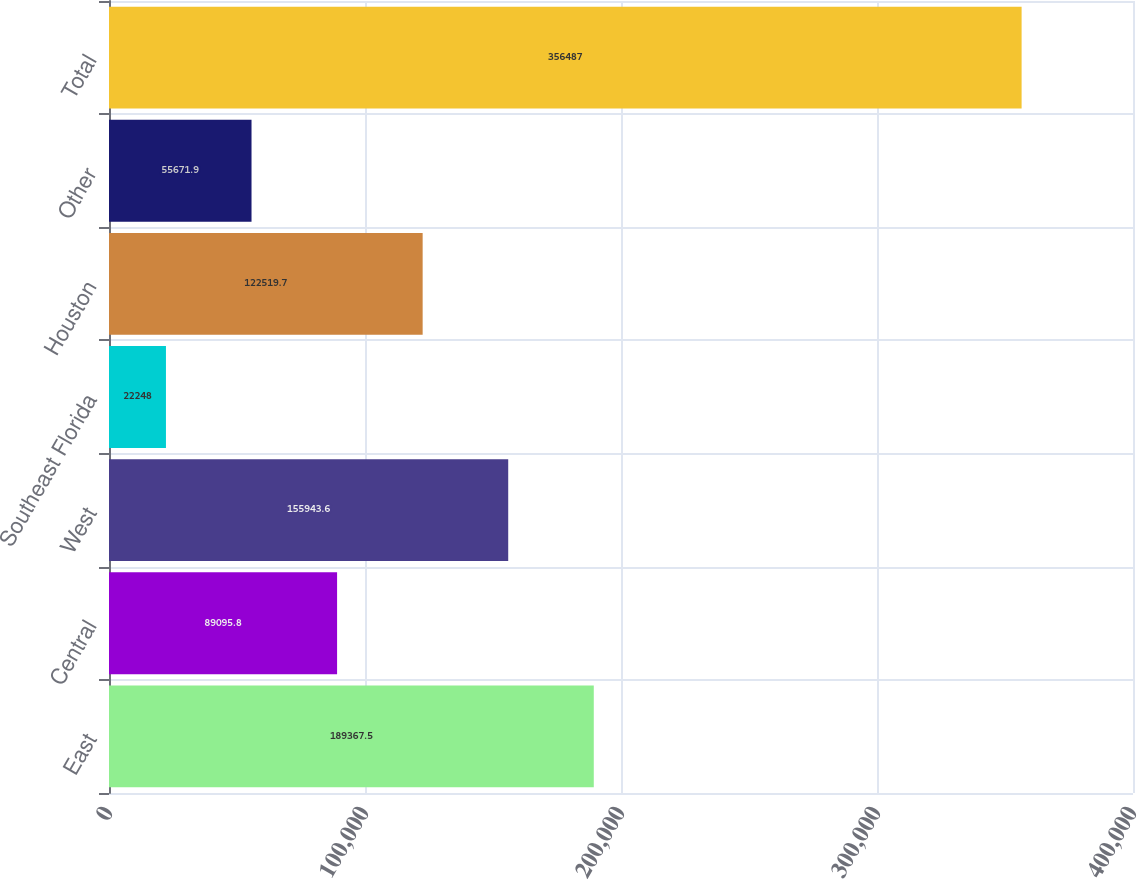Convert chart to OTSL. <chart><loc_0><loc_0><loc_500><loc_500><bar_chart><fcel>East<fcel>Central<fcel>West<fcel>Southeast Florida<fcel>Houston<fcel>Other<fcel>Total<nl><fcel>189368<fcel>89095.8<fcel>155944<fcel>22248<fcel>122520<fcel>55671.9<fcel>356487<nl></chart> 